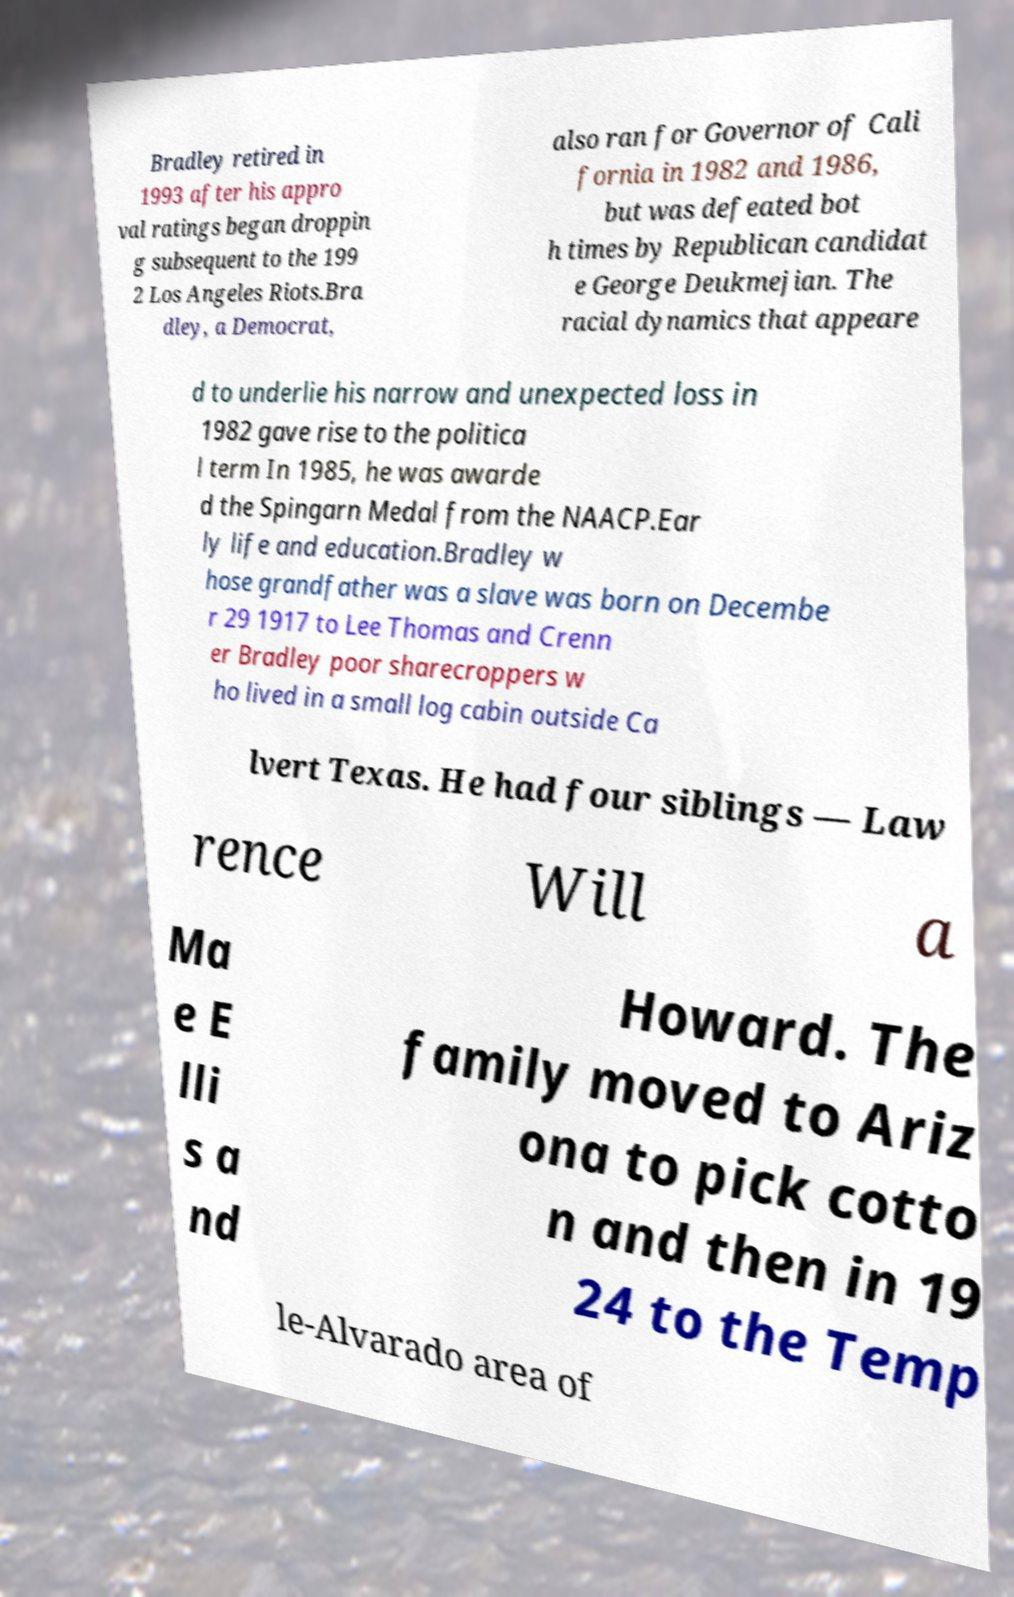Could you extract and type out the text from this image? Bradley retired in 1993 after his appro val ratings began droppin g subsequent to the 199 2 Los Angeles Riots.Bra dley, a Democrat, also ran for Governor of Cali fornia in 1982 and 1986, but was defeated bot h times by Republican candidat e George Deukmejian. The racial dynamics that appeare d to underlie his narrow and unexpected loss in 1982 gave rise to the politica l term In 1985, he was awarde d the Spingarn Medal from the NAACP.Ear ly life and education.Bradley w hose grandfather was a slave was born on Decembe r 29 1917 to Lee Thomas and Crenn er Bradley poor sharecroppers w ho lived in a small log cabin outside Ca lvert Texas. He had four siblings — Law rence Will a Ma e E lli s a nd Howard. The family moved to Ariz ona to pick cotto n and then in 19 24 to the Temp le-Alvarado area of 